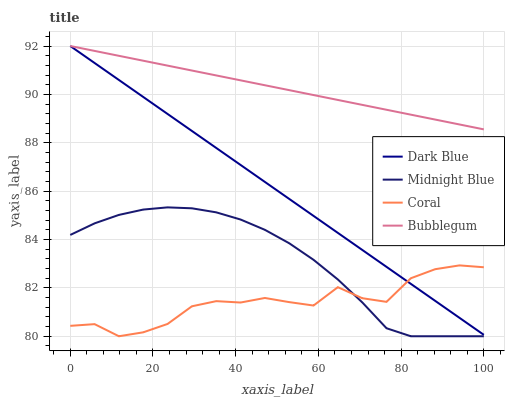Does Coral have the minimum area under the curve?
Answer yes or no. Yes. Does Bubblegum have the maximum area under the curve?
Answer yes or no. Yes. Does Midnight Blue have the minimum area under the curve?
Answer yes or no. No. Does Midnight Blue have the maximum area under the curve?
Answer yes or no. No. Is Dark Blue the smoothest?
Answer yes or no. Yes. Is Coral the roughest?
Answer yes or no. Yes. Is Midnight Blue the smoothest?
Answer yes or no. No. Is Midnight Blue the roughest?
Answer yes or no. No. Does Coral have the lowest value?
Answer yes or no. Yes. Does Bubblegum have the lowest value?
Answer yes or no. No. Does Bubblegum have the highest value?
Answer yes or no. Yes. Does Midnight Blue have the highest value?
Answer yes or no. No. Is Coral less than Bubblegum?
Answer yes or no. Yes. Is Bubblegum greater than Midnight Blue?
Answer yes or no. Yes. Does Bubblegum intersect Dark Blue?
Answer yes or no. Yes. Is Bubblegum less than Dark Blue?
Answer yes or no. No. Is Bubblegum greater than Dark Blue?
Answer yes or no. No. Does Coral intersect Bubblegum?
Answer yes or no. No. 